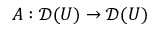Convert formula to latex. <formula><loc_0><loc_0><loc_500><loc_500>A \colon { \mathcal { D } } ( U ) \to { \mathcal { D } } ( U )</formula> 